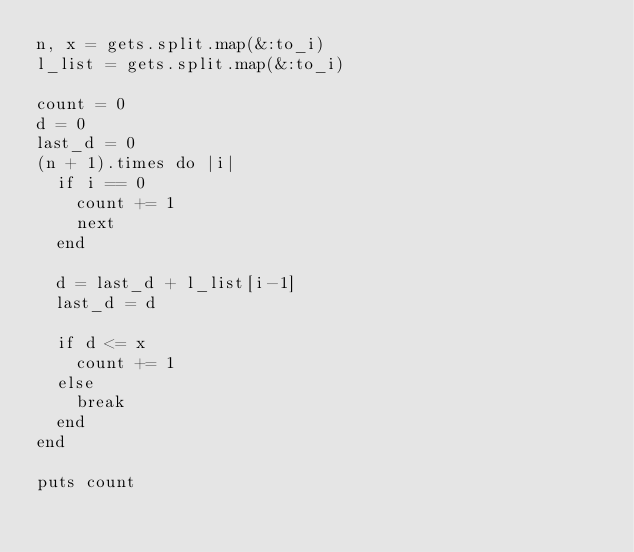<code> <loc_0><loc_0><loc_500><loc_500><_Ruby_>n, x = gets.split.map(&:to_i)
l_list = gets.split.map(&:to_i)

count = 0
d = 0
last_d = 0
(n + 1).times do |i|
  if i == 0
    count += 1
    next
  end
  
  d = last_d + l_list[i-1]
  last_d = d
  
  if d <= x
    count += 1
  else
    break
  end
end

puts count</code> 